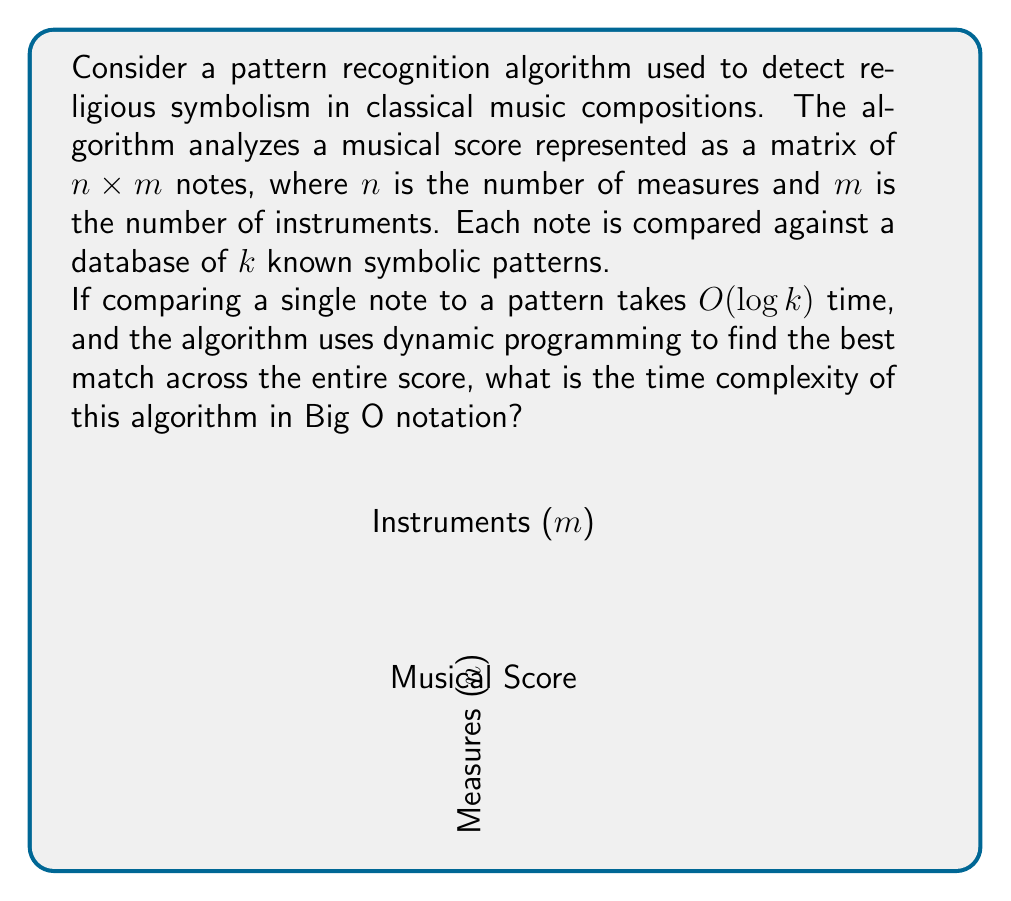Teach me how to tackle this problem. To solve this problem, let's break it down step by step:

1. First, we need to consider the total number of notes in the score:
   - There are $n$ measures and $m$ instruments
   - Total number of notes = $n \times m$

2. For each note, we need to compare it against $k$ patterns:
   - Comparison of a single note to a pattern takes $O(\log k)$ time
   - For each note, total comparison time = $O(k \log k)$

3. The dynamic programming approach typically requires filling a table:
   - The table size would be $O(nm)$ to cover all notes
   - For each cell, we need to consider all $k$ patterns

4. Combining these factors:
   - Time for all comparisons = $O(nmk \log k)$

5. The dynamic programming step adds an additional factor:
   - We need to fill $nm$ cells
   - For each cell, we perform $O(k \log k)$ operations

6. Therefore, the total time complexity is:
   $$O(nm \times k \log k) = O(nmk \log k)$$

This complexity accounts for comparing each note against all patterns and using dynamic programming to find the best overall match across the entire score.
Answer: $O(nmk \log k)$ 